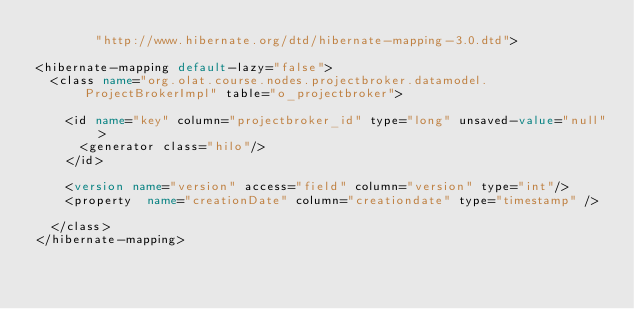<code> <loc_0><loc_0><loc_500><loc_500><_XML_>        "http://www.hibernate.org/dtd/hibernate-mapping-3.0.dtd">

<hibernate-mapping default-lazy="false">
  <class name="org.olat.course.nodes.projectbroker.datamodel.ProjectBrokerImpl" table="o_projectbroker">
  
    <id name="key" column="projectbroker_id" type="long" unsaved-value="null">
      <generator class="hilo"/>
    </id>

	<version name="version" access="field" column="version" type="int"/>
	<property  name="creationDate" column="creationdate" type="timestamp" />   
 	
  </class>  
</hibernate-mapping>

</code> 